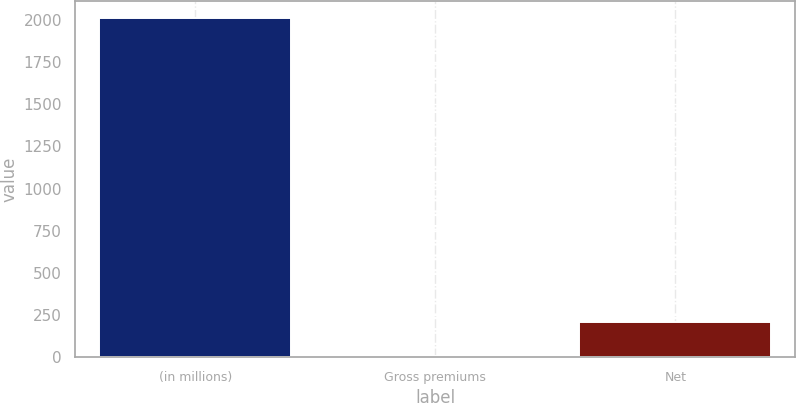<chart> <loc_0><loc_0><loc_500><loc_500><bar_chart><fcel>(in millions)<fcel>Gross premiums<fcel>Net<nl><fcel>2012<fcel>11<fcel>211.1<nl></chart> 